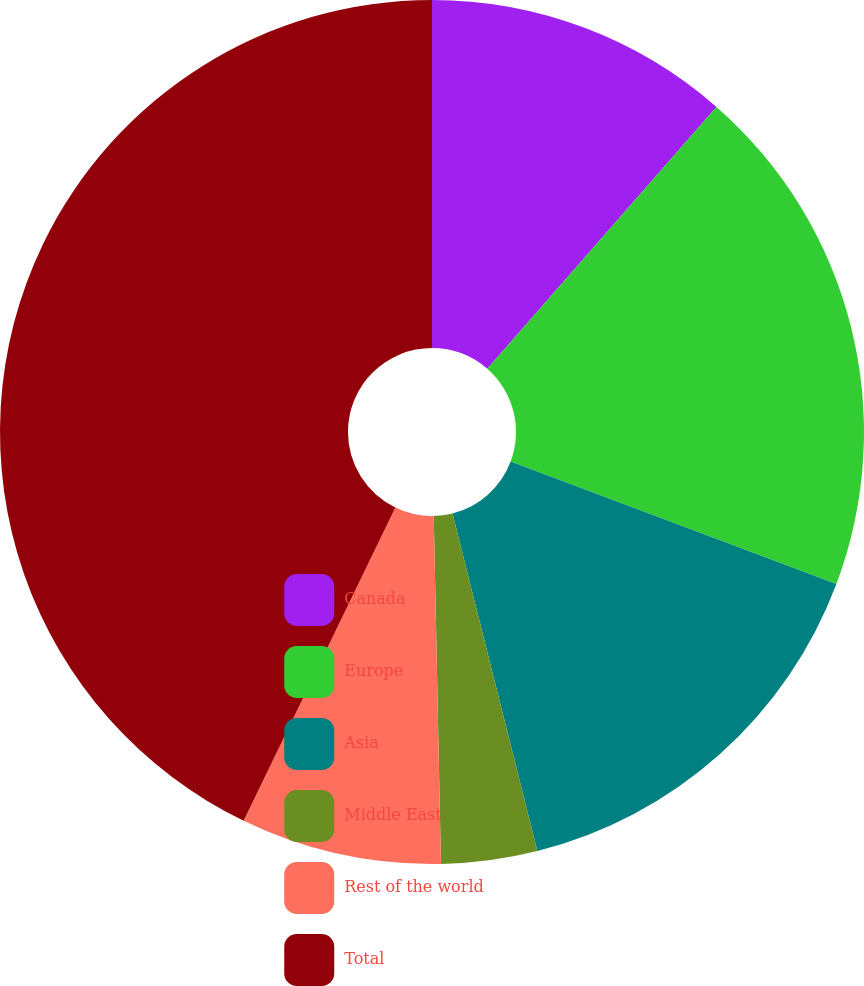Convert chart to OTSL. <chart><loc_0><loc_0><loc_500><loc_500><pie_chart><fcel>Canada<fcel>Europe<fcel>Asia<fcel>Middle East<fcel>Rest of the world<fcel>Total<nl><fcel>11.44%<fcel>19.28%<fcel>15.36%<fcel>3.59%<fcel>7.51%<fcel>42.82%<nl></chart> 